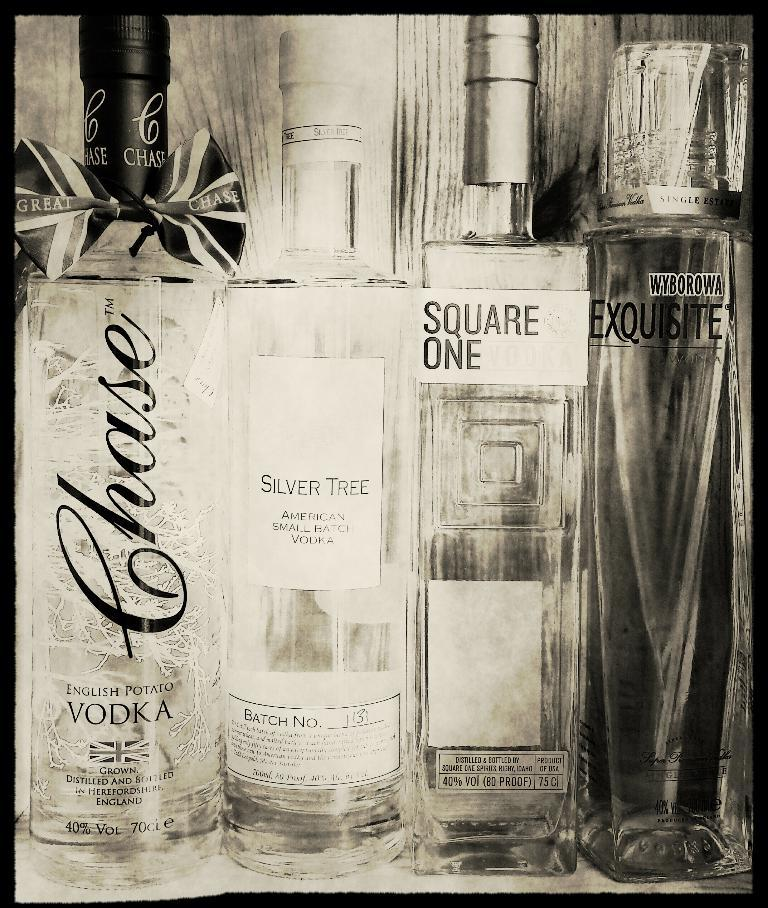<image>
Create a compact narrative representing the image presented. Four bottled of Vodka are pictured including one called SIlver Tree American small batch Vodka. 